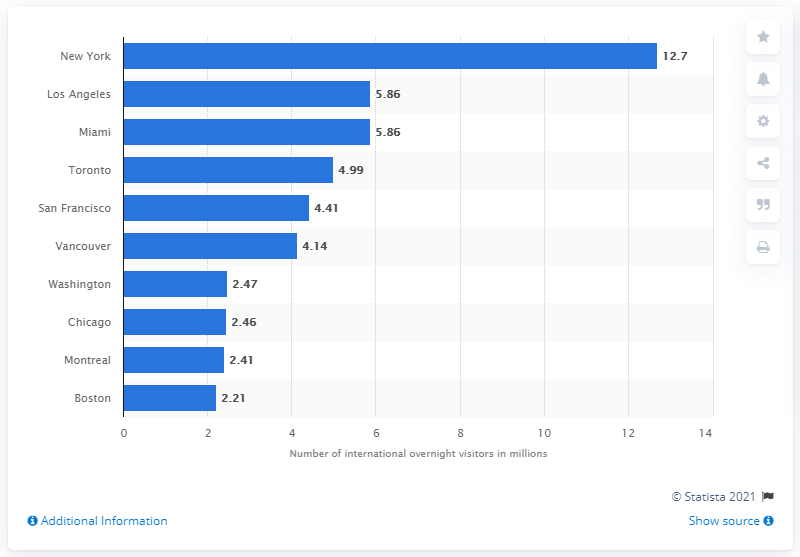Specify some key components in this picture. In 2016, New York City had the largest number of international overnight visitors among all cities. In 2016, New York welcomed 12.7 million international overnight visitors. 